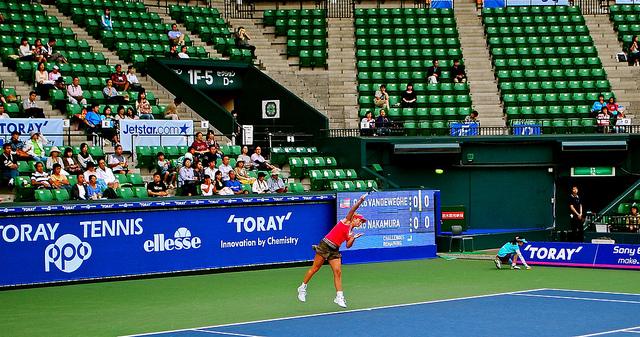What company is sponsoring the match?
Answer briefly. Toray. What tournament cup are they playing for?
Write a very short answer. Toray. What color are the seats the crowd is sitting on?
Answer briefly. Green. Are there many empty seats?
Be succinct. Yes. What is the woman kneeling down doing?
Be succinct. Fetching. 